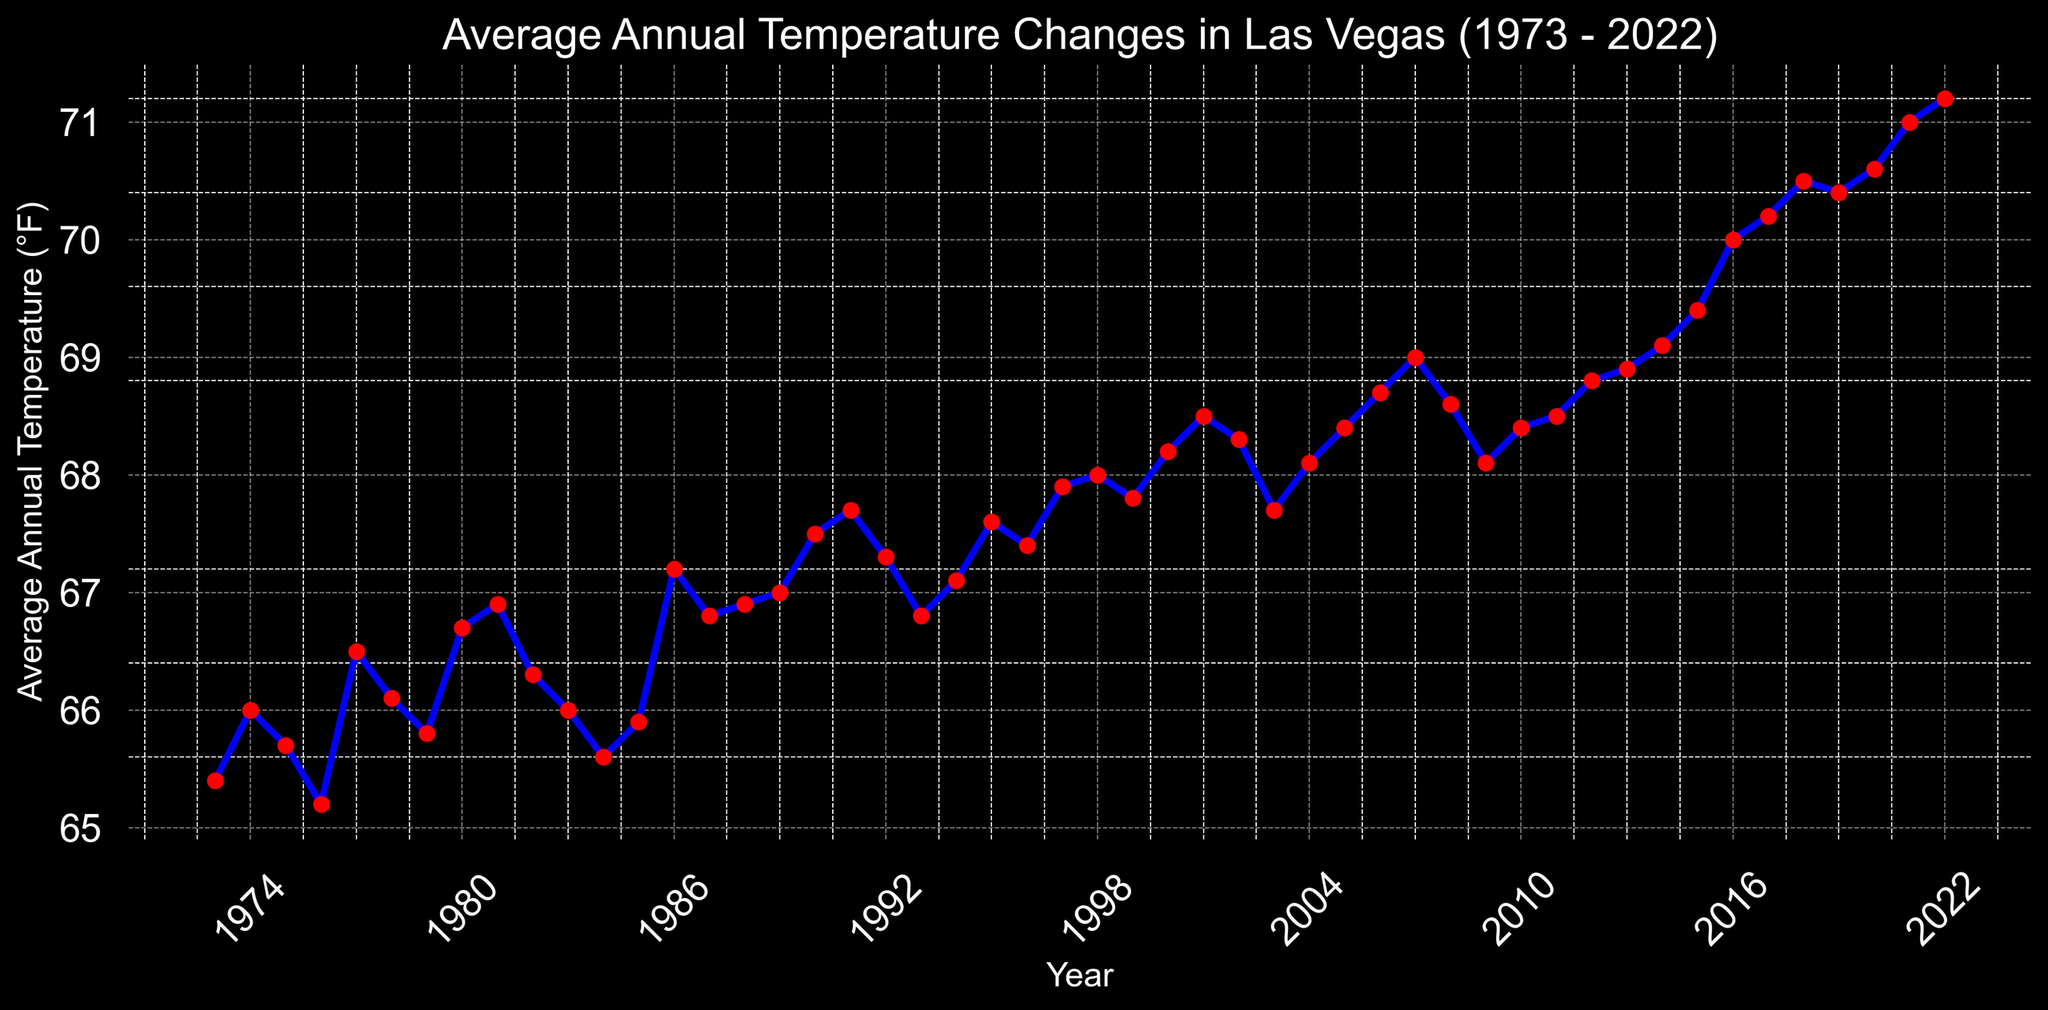What is the highest average annual temperature recorded and in which year? The highest point on the line graph indicates the maximum average annual temperature. By examining the graph, we can see the peak point and its corresponding year, which occurs in 2022 with a temperature of 71.2°F.
Answer: 71.2°F in 2022 What is the difference between the average annual temperature in 1973 and 2022? Locate the temperatures for 1973 and 2022 on the graph. The temperature in 1973 is 65.4°F, and in 2022 it is 71.2°F. Subtract the 1973 temperature from the 2022 temperature to find the difference: 71.2 - 65.4 = 5.8°F.
Answer: 5.8°F How many years had an average annual temperature above 70°F? Identify all the points on the graph where the temperature is above the 70°F line. These occur from 2016 to 2022, which gives us 7 years.
Answer: 7 years Which year had a temperature most similar to the average annual temperature in 1990? First, find the average annual temperature in 1990 (67.5°F). Then identify the point on the graph closest to this value. In 1991, the temperature is 67.7°F, which is the most similar.
Answer: 1991 What is the average annual temperature from 2000 to 2010? Identify the temperatures from 2000 to 2010, which are as follows:
2000: 68.2, 2001: 68.5, 2002: 68.3, 2003: 67.7, 2004: 68.1, 2005: 68.4, 2006: 68.7, 2007: 69.0, 2008: 68.6, 2009: 68.1, 2010: 68.4. Sum these values and divide by the number of years (11). 
(68.2 + 68.5 + 68.3 + 67.7 + 68.1 + 68.4 + 68.7 + 69.0 + 68.6 + 68.1 + 68.4) / 11 ≈ 68.3°F
Answer: 68.3°F In which decade did the average annual temperature show the most significant increase? Examine each decade's starting and ending temperatures, then calculate the difference:
- 1973-1982: 66.3 - 65.4 = 0.9°F
- 1983-1992: 67.3 - 66.0 = 1.3°F
- 1993-2002: 68.3 - 66.8 = 1.5°F
- 2003-2012: 68.8 - 67.7 = 1.1°F
- 2013-2022: 71.2 - 68.9 = 2.3°F 
The most significant increase is in the decade 2013-2022.
Answer: 2013-2022 What is the trend of average annual temperatures from 2010 to 2022? Identify the general direction of the line from 2010 to 2022. We see a steady rise from 68.4°F in 2010 to 71.2°F in 2022, indicating a clear increasing trend.
Answer: Increasing trend Did any year between 1973 and 2022 have the same average annual temperature as 1981? Determine the temperature for 1981 (66.9°F) and check for any other point in the graph with the same value. Both 1987 and 1988 have the same average annual temperature of 66.9°F.
Answer: 1987 and 1988 Which year had the largest one-year increase in average annual temperature? Examine the year-to-year changes and identify the largest difference. The increase from 2015 to 2016 is the greatest, rising from 69.4°F to 70.0°F, a difference of 0.6°F.
Answer: 2016 What visual pattern can be observed for the temperatures between 1973 and 2022? Observe the overall shape of the graph. The visual pattern shows a general upward trend with some fluctuations, indicating rising average annual temperatures over the 50-year period.
Answer: General upward trend 